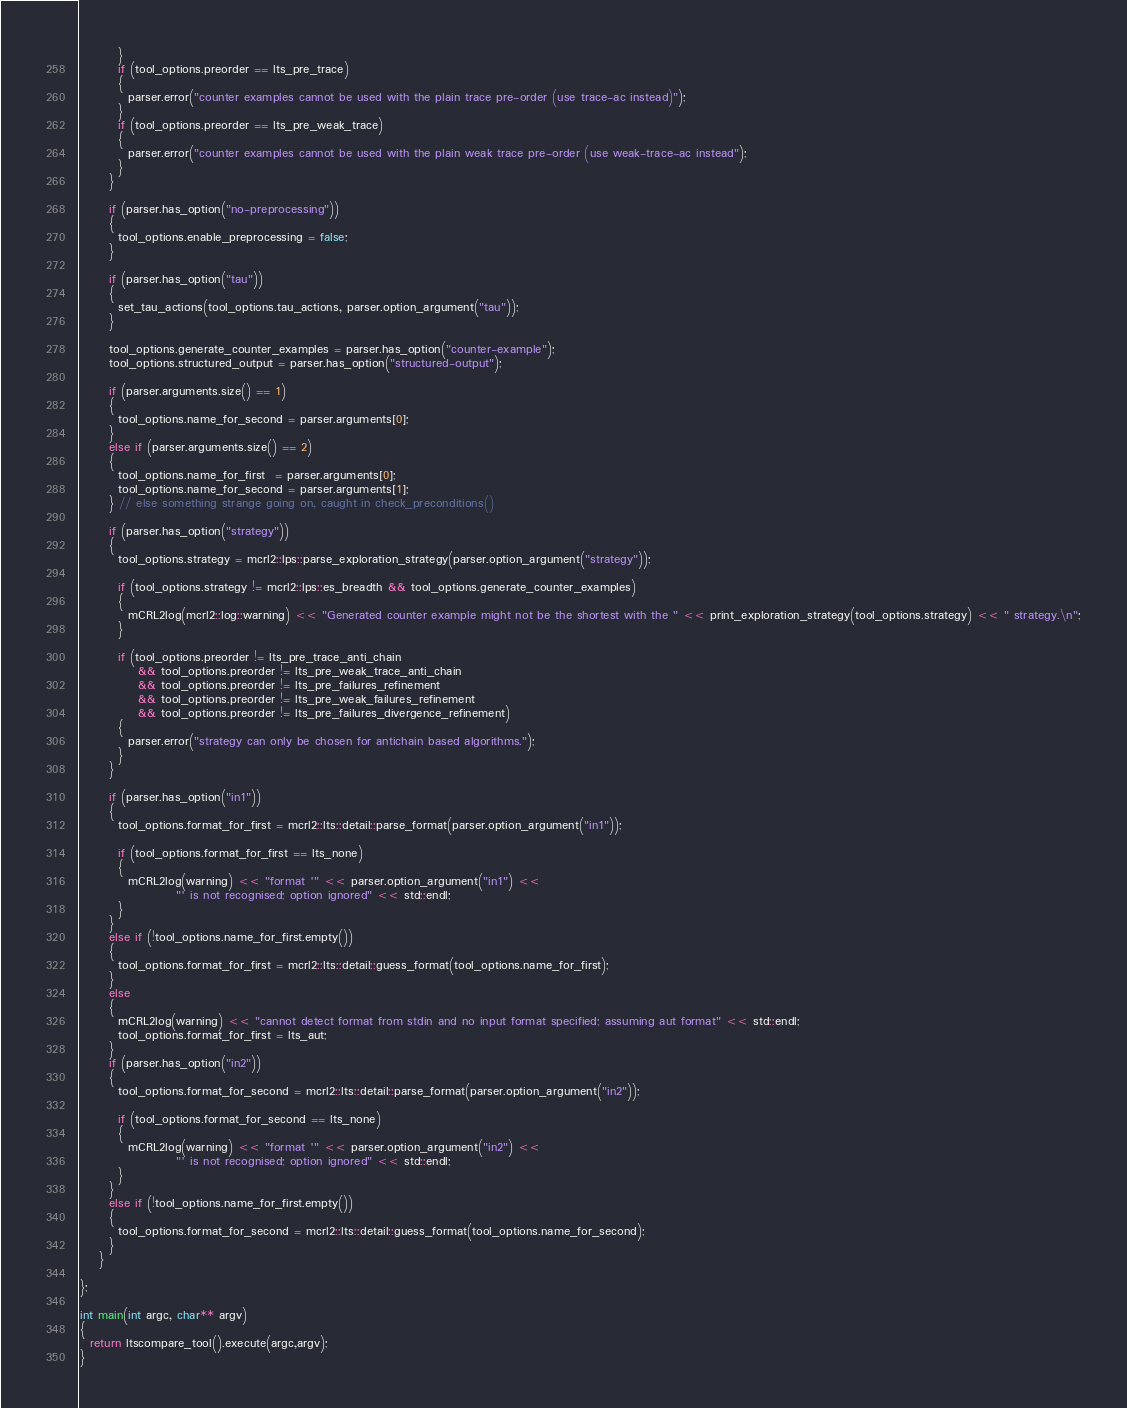<code> <loc_0><loc_0><loc_500><loc_500><_C++_>        }
        if (tool_options.preorder == lts_pre_trace)
        {
          parser.error("counter examples cannot be used with the plain trace pre-order (use trace-ac instead)");
        }
        if (tool_options.preorder == lts_pre_weak_trace)
        {
          parser.error("counter examples cannot be used with the plain weak trace pre-order (use weak-trace-ac instead");
        }
      }

      if (parser.has_option("no-preprocessing"))
      {
        tool_options.enable_preprocessing = false;
      }

      if (parser.has_option("tau"))
      {
        set_tau_actions(tool_options.tau_actions, parser.option_argument("tau"));
      }

      tool_options.generate_counter_examples = parser.has_option("counter-example");
      tool_options.structured_output = parser.has_option("structured-output");

      if (parser.arguments.size() == 1)
      {
        tool_options.name_for_second = parser.arguments[0];
      }
      else if (parser.arguments.size() == 2)
      {
        tool_options.name_for_first  = parser.arguments[0];
        tool_options.name_for_second = parser.arguments[1];
      } // else something strange going on, caught in check_preconditions()

      if (parser.has_option("strategy"))
      {
        tool_options.strategy = mcrl2::lps::parse_exploration_strategy(parser.option_argument("strategy"));

        if (tool_options.strategy != mcrl2::lps::es_breadth && tool_options.generate_counter_examples)
        {
          mCRL2log(mcrl2::log::warning) << "Generated counter example might not be the shortest with the " << print_exploration_strategy(tool_options.strategy) << " strategy.\n";
        }

        if (tool_options.preorder != lts_pre_trace_anti_chain
            && tool_options.preorder != lts_pre_weak_trace_anti_chain
            && tool_options.preorder != lts_pre_failures_refinement
            && tool_options.preorder != lts_pre_weak_failures_refinement
            && tool_options.preorder != lts_pre_failures_divergence_refinement)
        {
          parser.error("strategy can only be chosen for antichain based algorithms.");
        }
      }

      if (parser.has_option("in1"))
      {
        tool_options.format_for_first = mcrl2::lts::detail::parse_format(parser.option_argument("in1"));

        if (tool_options.format_for_first == lts_none)
        {
          mCRL2log(warning) << "format '" << parser.option_argument("in1") <<
                    "' is not recognised; option ignored" << std::endl;
        }
      }
      else if (!tool_options.name_for_first.empty())
      {
        tool_options.format_for_first = mcrl2::lts::detail::guess_format(tool_options.name_for_first);
      }
      else
      {
        mCRL2log(warning) << "cannot detect format from stdin and no input format specified; assuming aut format" << std::endl;
        tool_options.format_for_first = lts_aut;
      }
      if (parser.has_option("in2"))
      {
        tool_options.format_for_second = mcrl2::lts::detail::parse_format(parser.option_argument("in2"));

        if (tool_options.format_for_second == lts_none)
        {
          mCRL2log(warning) << "format '" << parser.option_argument("in2") <<
                    "' is not recognised; option ignored" << std::endl;
        }
      }
      else if (!tool_options.name_for_first.empty())
      {
        tool_options.format_for_second = mcrl2::lts::detail::guess_format(tool_options.name_for_second);
      }
    }

};

int main(int argc, char** argv)
{
  return ltscompare_tool().execute(argc,argv);
}
</code> 